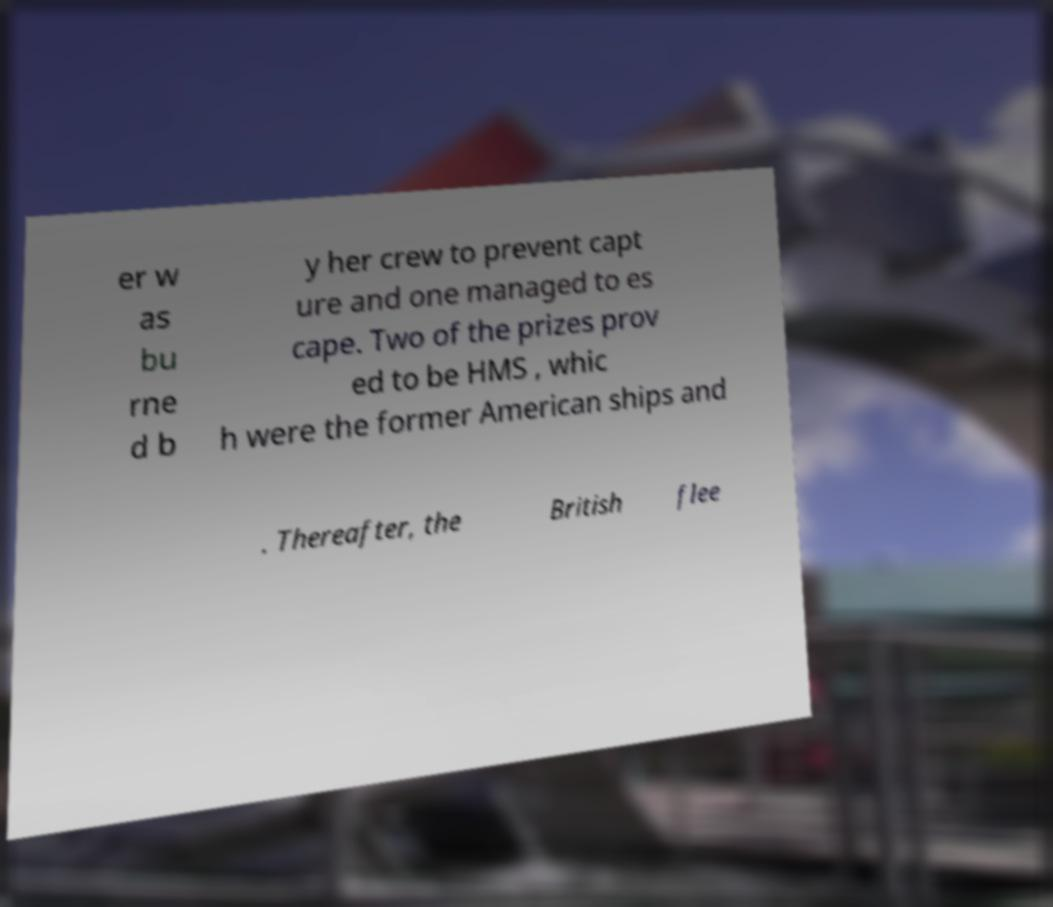Please identify and transcribe the text found in this image. er w as bu rne d b y her crew to prevent capt ure and one managed to es cape. Two of the prizes prov ed to be HMS , whic h were the former American ships and . Thereafter, the British flee 